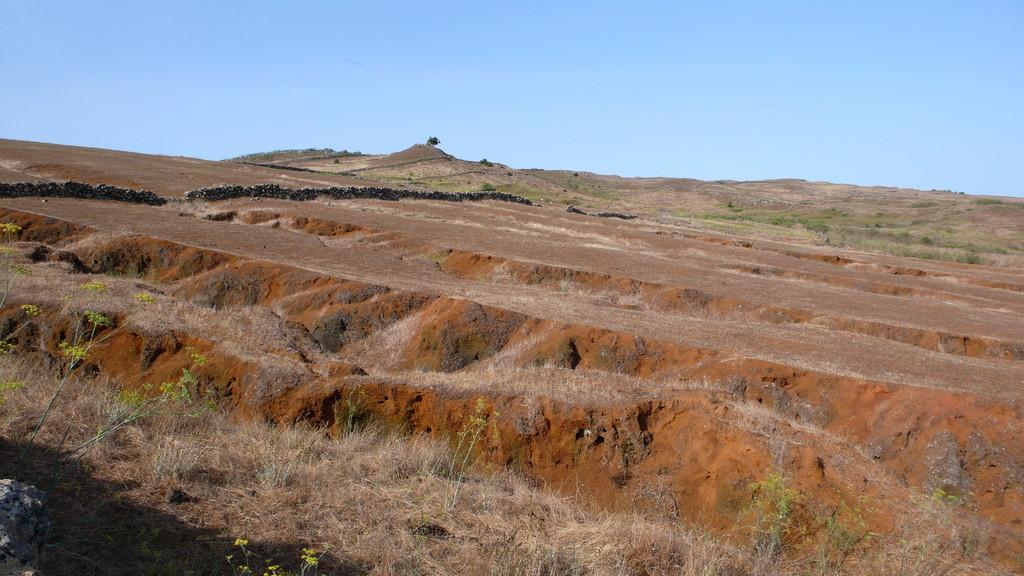In one or two sentences, can you explain what this image depicts? In this image, we can see some plants and grass on the ground. There is a sky at the top of the image. 